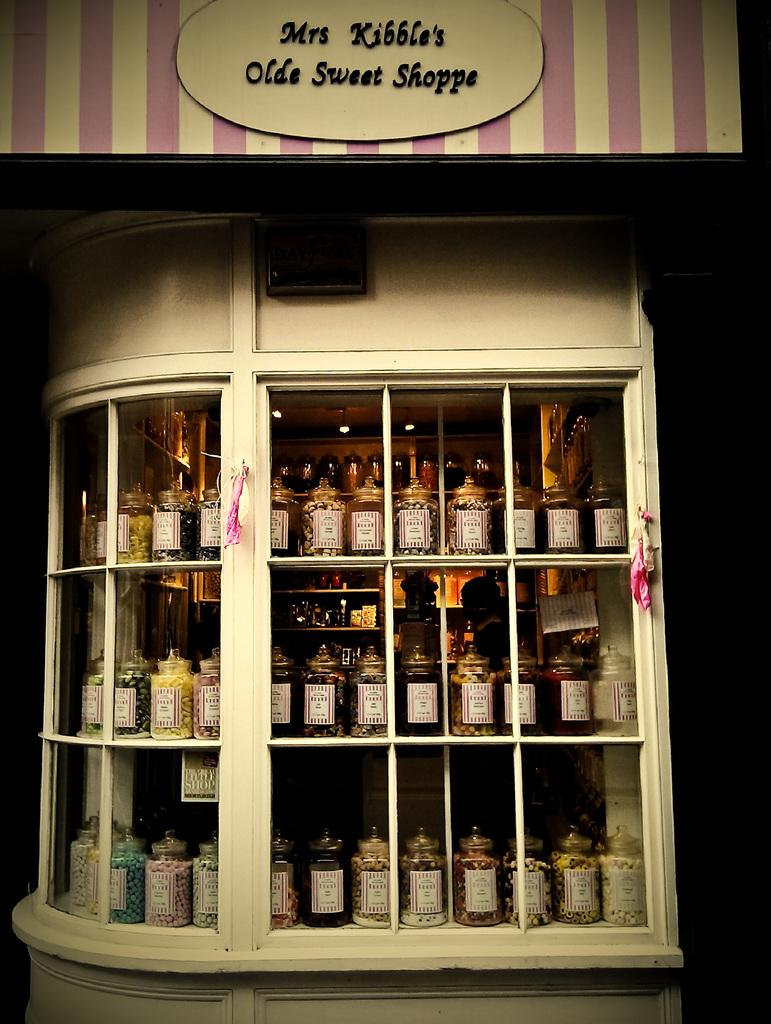<image>
Describe the image concisely. The exterior of Mrs Kibble's Old Sweet Shop shows us rows of sweety jars sitting in the window. 